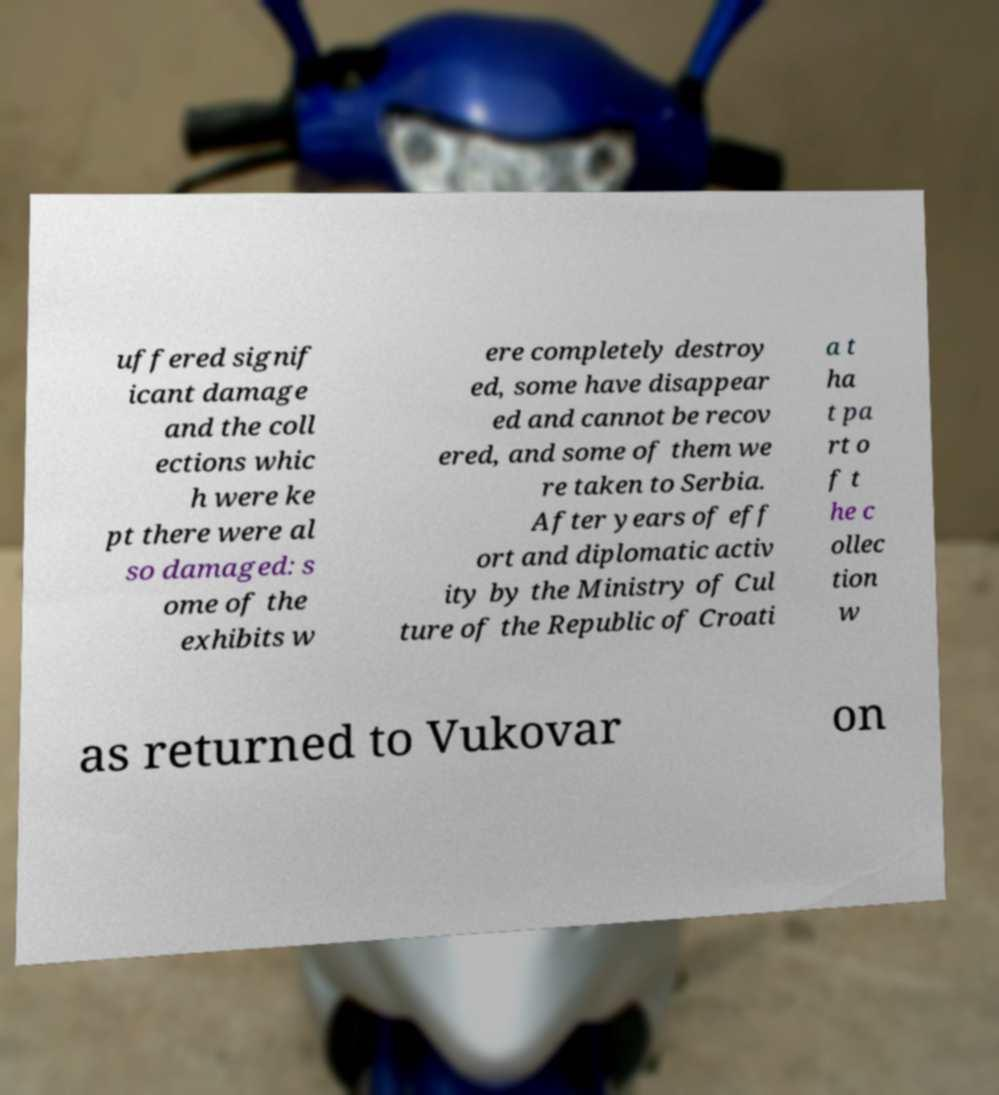Could you assist in decoding the text presented in this image and type it out clearly? uffered signif icant damage and the coll ections whic h were ke pt there were al so damaged: s ome of the exhibits w ere completely destroy ed, some have disappear ed and cannot be recov ered, and some of them we re taken to Serbia. After years of eff ort and diplomatic activ ity by the Ministry of Cul ture of the Republic of Croati a t ha t pa rt o f t he c ollec tion w as returned to Vukovar on 